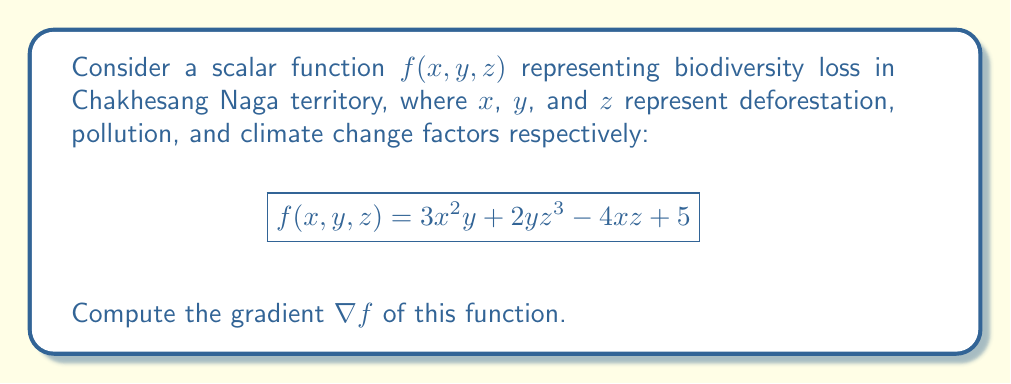Can you solve this math problem? To compute the gradient of the scalar function $f(x, y, z)$, we need to calculate the partial derivatives with respect to each variable:

1. Calculate $\frac{\partial f}{\partial x}$:
   $$\frac{\partial f}{\partial x} = \frac{\partial}{\partial x}(3x^2y + 2yz^3 - 4xz + 5) = 6xy - 4z$$

2. Calculate $\frac{\partial f}{\partial y}$:
   $$\frac{\partial f}{\partial y} = \frac{\partial}{\partial y}(3x^2y + 2yz^3 - 4xz + 5) = 3x^2 + 2z^3$$

3. Calculate $\frac{\partial f}{\partial z}$:
   $$\frac{\partial f}{\partial z} = \frac{\partial}{\partial z}(3x^2y + 2yz^3 - 4xz + 5) = 6yz^2 - 4x$$

The gradient $\nabla f$ is the vector of these partial derivatives:

$$\nabla f = \left(\frac{\partial f}{\partial x}, \frac{\partial f}{\partial y}, \frac{\partial f}{\partial z}\right)$$

Substituting the calculated partial derivatives:

$$\nabla f = (6xy - 4z, 3x^2 + 2z^3, 6yz^2 - 4x)$$
Answer: $\nabla f = (6xy - 4z, 3x^2 + 2z^3, 6yz^2 - 4x)$ 